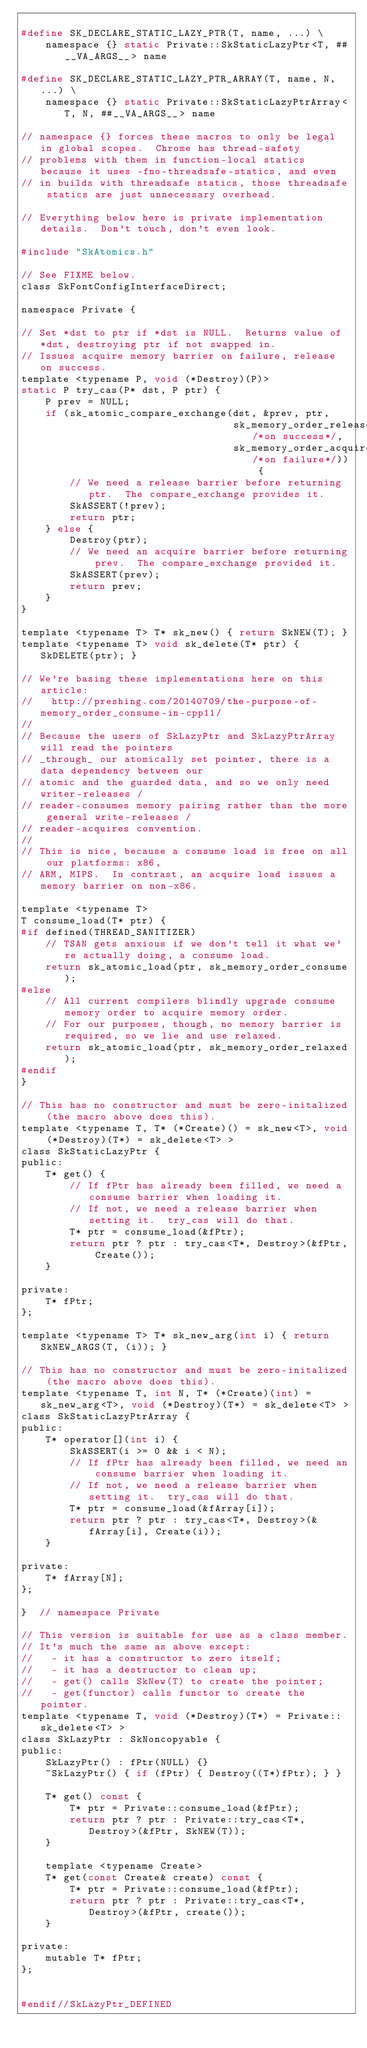Convert code to text. <code><loc_0><loc_0><loc_500><loc_500><_C_>
#define SK_DECLARE_STATIC_LAZY_PTR(T, name, ...) \
    namespace {} static Private::SkStaticLazyPtr<T, ##__VA_ARGS__> name

#define SK_DECLARE_STATIC_LAZY_PTR_ARRAY(T, name, N, ...) \
    namespace {} static Private::SkStaticLazyPtrArray<T, N, ##__VA_ARGS__> name

// namespace {} forces these macros to only be legal in global scopes.  Chrome has thread-safety
// problems with them in function-local statics because it uses -fno-threadsafe-statics, and even
// in builds with threadsafe statics, those threadsafe statics are just unnecessary overhead.

// Everything below here is private implementation details.  Don't touch, don't even look.

#include "SkAtomics.h"

// See FIXME below.
class SkFontConfigInterfaceDirect;

namespace Private {

// Set *dst to ptr if *dst is NULL.  Returns value of *dst, destroying ptr if not swapped in.
// Issues acquire memory barrier on failure, release on success.
template <typename P, void (*Destroy)(P)>
static P try_cas(P* dst, P ptr) {
    P prev = NULL;
    if (sk_atomic_compare_exchange(dst, &prev, ptr,
                                   sk_memory_order_release/*on success*/,
                                   sk_memory_order_acquire/*on failure*/)) {
        // We need a release barrier before returning ptr.  The compare_exchange provides it.
        SkASSERT(!prev);
        return ptr;
    } else {
        Destroy(ptr);
        // We need an acquire barrier before returning prev.  The compare_exchange provided it.
        SkASSERT(prev);
        return prev;
    }
}

template <typename T> T* sk_new() { return SkNEW(T); }
template <typename T> void sk_delete(T* ptr) { SkDELETE(ptr); }

// We're basing these implementations here on this article:
//   http://preshing.com/20140709/the-purpose-of-memory_order_consume-in-cpp11/
//
// Because the users of SkLazyPtr and SkLazyPtrArray will read the pointers
// _through_ our atomically set pointer, there is a data dependency between our
// atomic and the guarded data, and so we only need writer-releases /
// reader-consumes memory pairing rather than the more general write-releases /
// reader-acquires convention.
//
// This is nice, because a consume load is free on all our platforms: x86,
// ARM, MIPS.  In contrast, an acquire load issues a memory barrier on non-x86.

template <typename T>
T consume_load(T* ptr) {
#if defined(THREAD_SANITIZER)
    // TSAN gets anxious if we don't tell it what we're actually doing, a consume load.
    return sk_atomic_load(ptr, sk_memory_order_consume);
#else
    // All current compilers blindly upgrade consume memory order to acquire memory order.
    // For our purposes, though, no memory barrier is required, so we lie and use relaxed.
    return sk_atomic_load(ptr, sk_memory_order_relaxed);
#endif
}

// This has no constructor and must be zero-initalized (the macro above does this).
template <typename T, T* (*Create)() = sk_new<T>, void (*Destroy)(T*) = sk_delete<T> >
class SkStaticLazyPtr {
public:
    T* get() {
        // If fPtr has already been filled, we need a consume barrier when loading it.
        // If not, we need a release barrier when setting it.  try_cas will do that.
        T* ptr = consume_load(&fPtr);
        return ptr ? ptr : try_cas<T*, Destroy>(&fPtr, Create());
    }

private:
    T* fPtr;
};

template <typename T> T* sk_new_arg(int i) { return SkNEW_ARGS(T, (i)); }

// This has no constructor and must be zero-initalized (the macro above does this).
template <typename T, int N, T* (*Create)(int) = sk_new_arg<T>, void (*Destroy)(T*) = sk_delete<T> >
class SkStaticLazyPtrArray {
public:
    T* operator[](int i) {
        SkASSERT(i >= 0 && i < N);
        // If fPtr has already been filled, we need an consume barrier when loading it.
        // If not, we need a release barrier when setting it.  try_cas will do that.
        T* ptr = consume_load(&fArray[i]);
        return ptr ? ptr : try_cas<T*, Destroy>(&fArray[i], Create(i));
    }

private:
    T* fArray[N];
};

}  // namespace Private

// This version is suitable for use as a class member.
// It's much the same as above except:
//   - it has a constructor to zero itself;
//   - it has a destructor to clean up;
//   - get() calls SkNew(T) to create the pointer;
//   - get(functor) calls functor to create the pointer.
template <typename T, void (*Destroy)(T*) = Private::sk_delete<T> >
class SkLazyPtr : SkNoncopyable {
public:
    SkLazyPtr() : fPtr(NULL) {}
    ~SkLazyPtr() { if (fPtr) { Destroy((T*)fPtr); } }

    T* get() const {
        T* ptr = Private::consume_load(&fPtr);
        return ptr ? ptr : Private::try_cas<T*, Destroy>(&fPtr, SkNEW(T));
    }

    template <typename Create>
    T* get(const Create& create) const {
        T* ptr = Private::consume_load(&fPtr);
        return ptr ? ptr : Private::try_cas<T*, Destroy>(&fPtr, create());
    }

private:
    mutable T* fPtr;
};


#endif//SkLazyPtr_DEFINED
</code> 